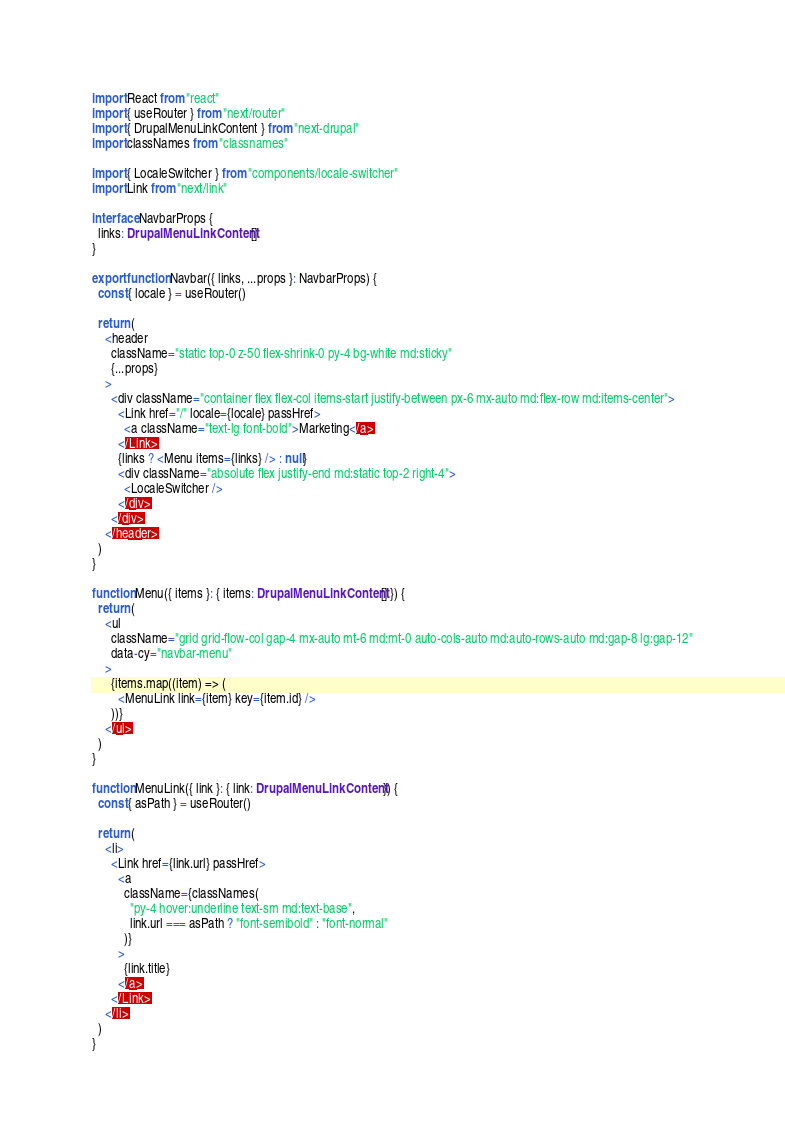Convert code to text. <code><loc_0><loc_0><loc_500><loc_500><_TypeScript_>import React from "react"
import { useRouter } from "next/router"
import { DrupalMenuLinkContent } from "next-drupal"
import classNames from "classnames"

import { LocaleSwitcher } from "components/locale-switcher"
import Link from "next/link"

interface NavbarProps {
  links: DrupalMenuLinkContent[]
}

export function Navbar({ links, ...props }: NavbarProps) {
  const { locale } = useRouter()

  return (
    <header
      className="static top-0 z-50 flex-shrink-0 py-4 bg-white md:sticky"
      {...props}
    >
      <div className="container flex flex-col items-start justify-between px-6 mx-auto md:flex-row md:items-center">
        <Link href="/" locale={locale} passHref>
          <a className="text-lg font-bold">Marketing</a>
        </Link>
        {links ? <Menu items={links} /> : null}
        <div className="absolute flex justify-end md:static top-2 right-4">
          <LocaleSwitcher />
        </div>
      </div>
    </header>
  )
}

function Menu({ items }: { items: DrupalMenuLinkContent[] }) {
  return (
    <ul
      className="grid grid-flow-col gap-4 mx-auto mt-6 md:mt-0 auto-cols-auto md:auto-rows-auto md:gap-8 lg:gap-12"
      data-cy="navbar-menu"
    >
      {items.map((item) => (
        <MenuLink link={item} key={item.id} />
      ))}
    </ul>
  )
}

function MenuLink({ link }: { link: DrupalMenuLinkContent }) {
  const { asPath } = useRouter()

  return (
    <li>
      <Link href={link.url} passHref>
        <a
          className={classNames(
            "py-4 hover:underline text-sm md:text-base",
            link.url === asPath ? "font-semibold" : "font-normal"
          )}
        >
          {link.title}
        </a>
      </Link>
    </li>
  )
}
</code> 